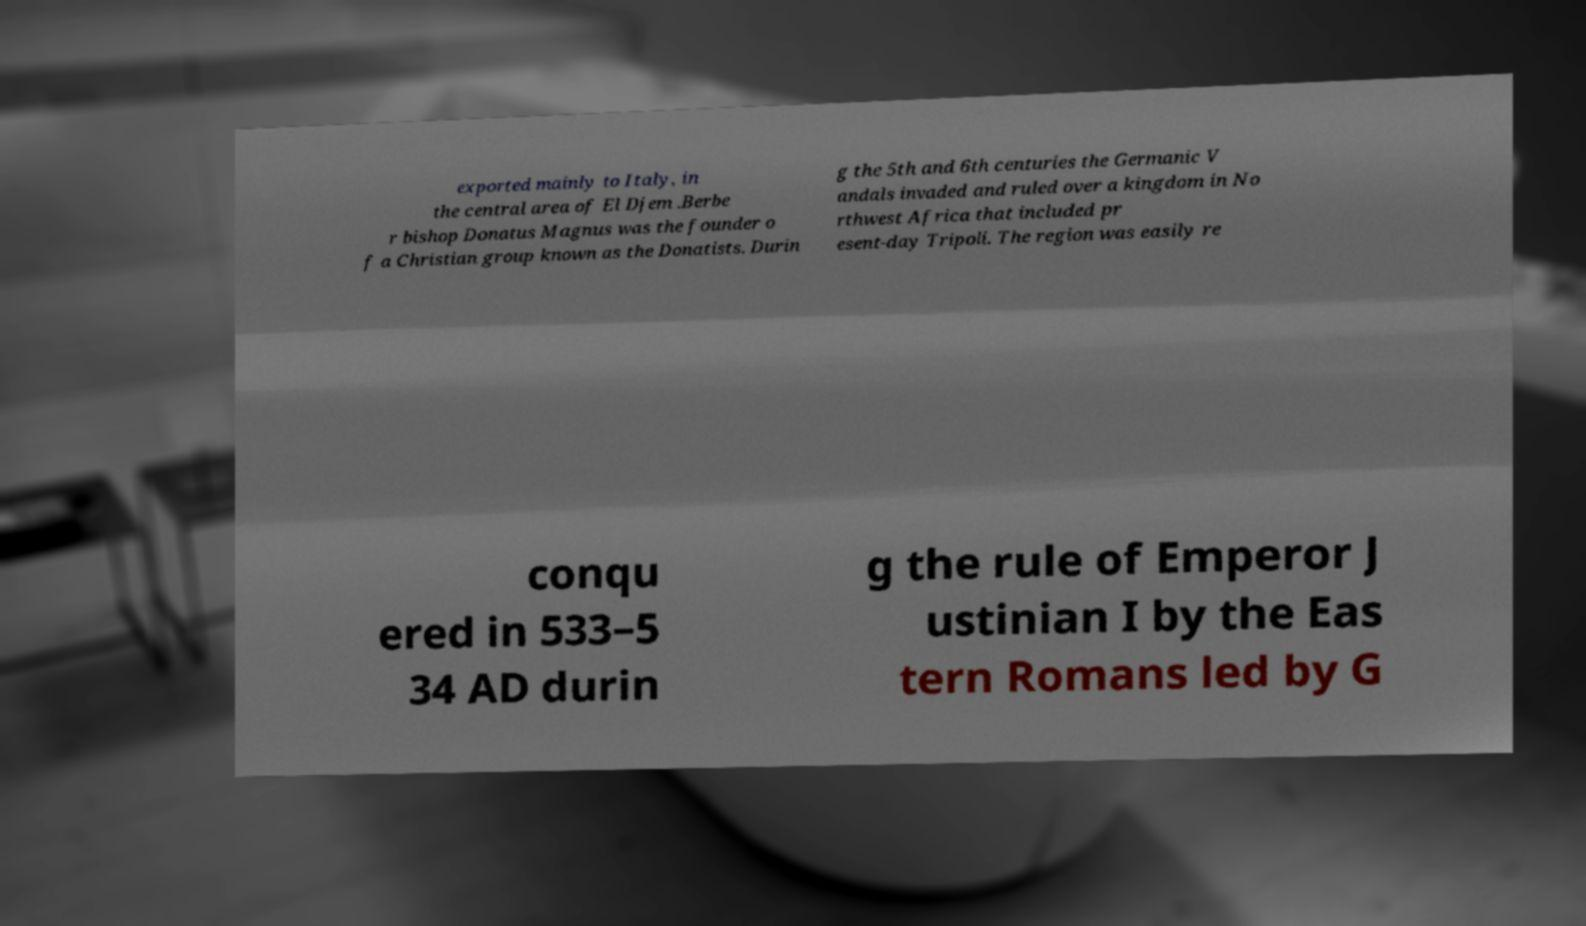Can you accurately transcribe the text from the provided image for me? exported mainly to Italy, in the central area of El Djem .Berbe r bishop Donatus Magnus was the founder o f a Christian group known as the Donatists. Durin g the 5th and 6th centuries the Germanic V andals invaded and ruled over a kingdom in No rthwest Africa that included pr esent-day Tripoli. The region was easily re conqu ered in 533–5 34 AD durin g the rule of Emperor J ustinian I by the Eas tern Romans led by G 